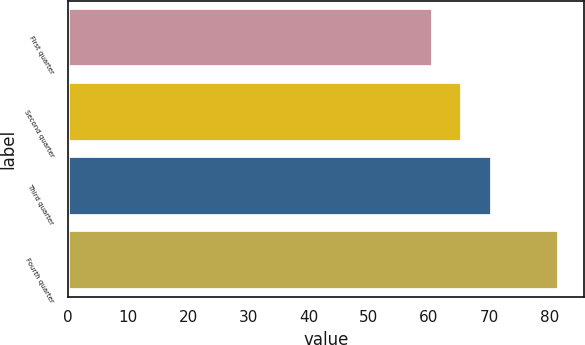Convert chart. <chart><loc_0><loc_0><loc_500><loc_500><bar_chart><fcel>First quarter<fcel>Second quarter<fcel>Third quarter<fcel>Fourth quarter<nl><fcel>60.69<fcel>65.5<fcel>70.55<fcel>81.64<nl></chart> 